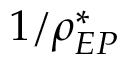<formula> <loc_0><loc_0><loc_500><loc_500>1 / \rho _ { E P } ^ { * }</formula> 